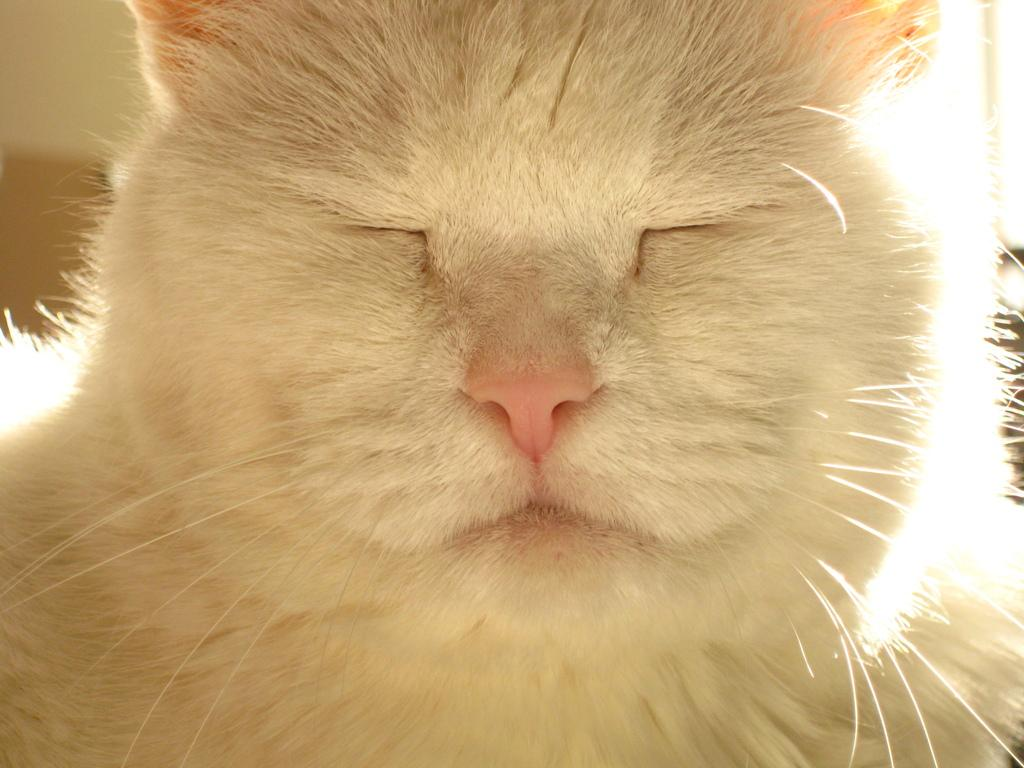What animal is present in the picture? There is a cat in the picture. What is the color of the cat? The cat is white in color. What is the cat doing in the picture? The cat is closing its eyes. How does the cat demonstrate its knowledge of quantum physics in the image? The cat does not demonstrate any knowledge of quantum physics in the image; it is simply closing its eyes. 